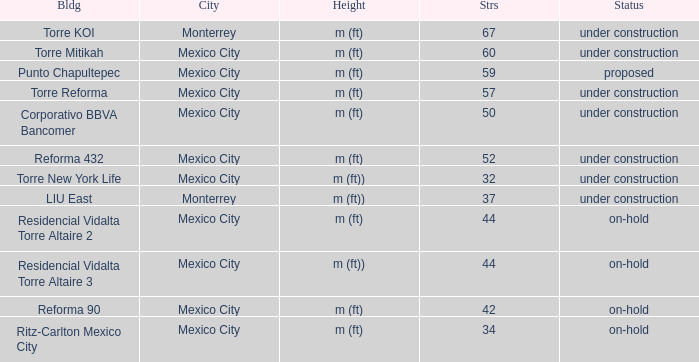How tall is the 52 story building? M (ft). 